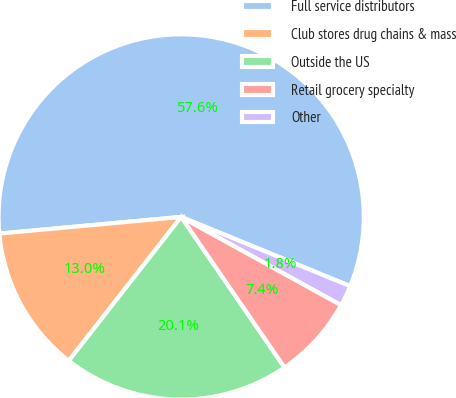Convert chart to OTSL. <chart><loc_0><loc_0><loc_500><loc_500><pie_chart><fcel>Full service distributors<fcel>Club stores drug chains & mass<fcel>Outside the US<fcel>Retail grocery specialty<fcel>Other<nl><fcel>57.64%<fcel>12.99%<fcel>20.13%<fcel>7.41%<fcel>1.83%<nl></chart> 